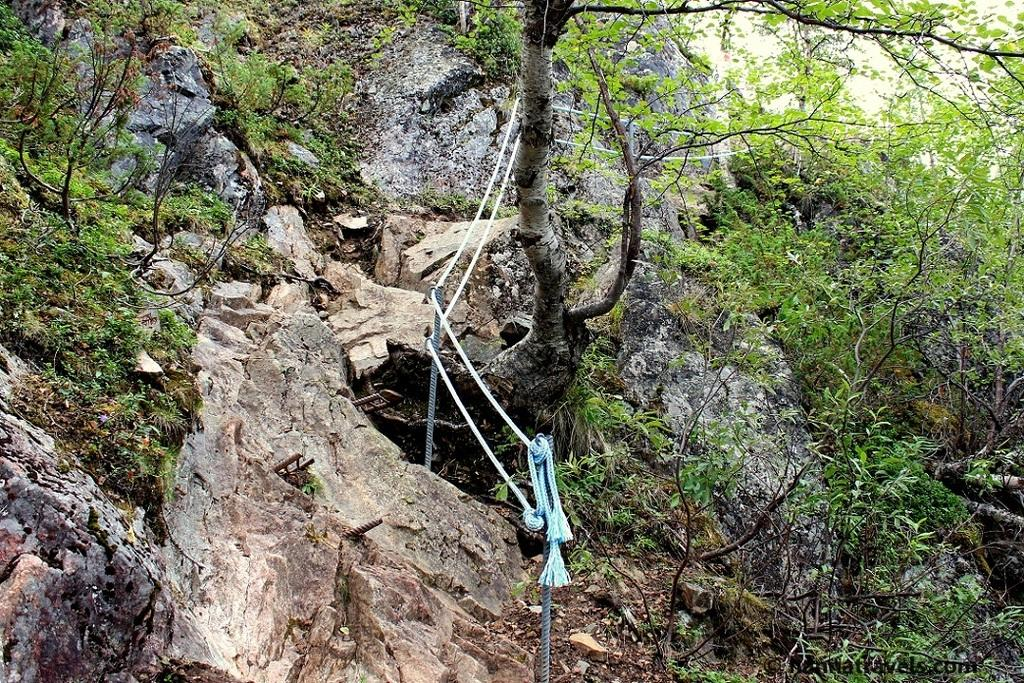What type of landscape feature is present in the image? There is a hill in the image. What can be found on the hill? There are trees and rocks on the hill. Can you describe any other objects in the image? There are ropes with poles in the image. What type of tin can be seen hanging from the trees on the hill? There is no tin present in the image; it features a hill with trees and rocks, as well as ropes with poles. What color is the skirt worn by the tree on the hill? Trees do not wear skirts, and there are no people or clothing items present in the image. 